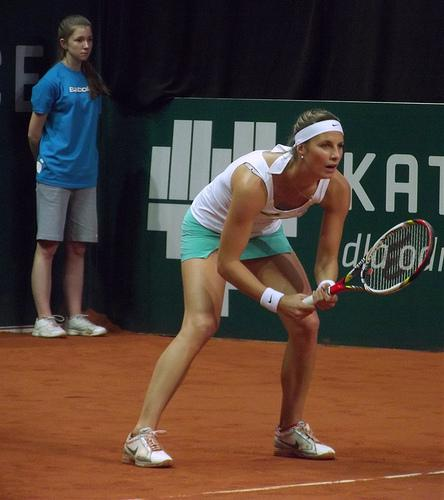Question: what sport is being played?
Choices:
A. Hockey.
B. Tennis.
C. Soccer.
D. Football.
Answer with the letter. Answer: B Question: who is playing tennis?
Choices:
A. A man.
B. Kids.
C. Professionals.
D. A woman.
Answer with the letter. Answer: D Question: where is the game being played?
Choices:
A. In a stadium.
B. On television.
C. Live.
D. Tennis court.
Answer with the letter. Answer: D Question: what is the gender of the person playing tennis?
Choices:
A. Man.
B. Female.
C. Girl.
D. Boy.
Answer with the letter. Answer: B 